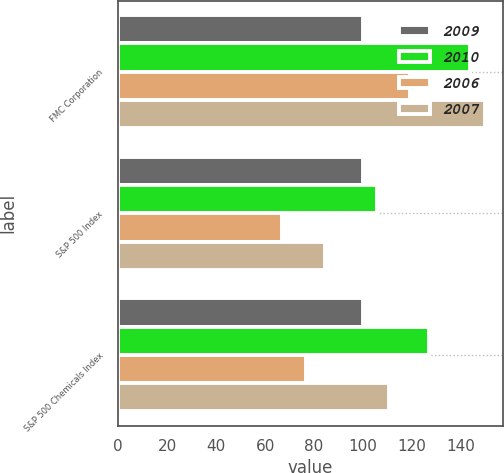<chart> <loc_0><loc_0><loc_500><loc_500><stacked_bar_chart><ecel><fcel>FMC Corporation<fcel>S&P 500 Index<fcel>S&P 500 Chemicals Index<nl><fcel>2009<fcel>100<fcel>100<fcel>100<nl><fcel>2010<fcel>143.58<fcel>105.48<fcel>126.73<nl><fcel>2006<fcel>119<fcel>66.96<fcel>76.66<nl><fcel>2007<fcel>149.67<fcel>84.33<fcel>110.47<nl></chart> 